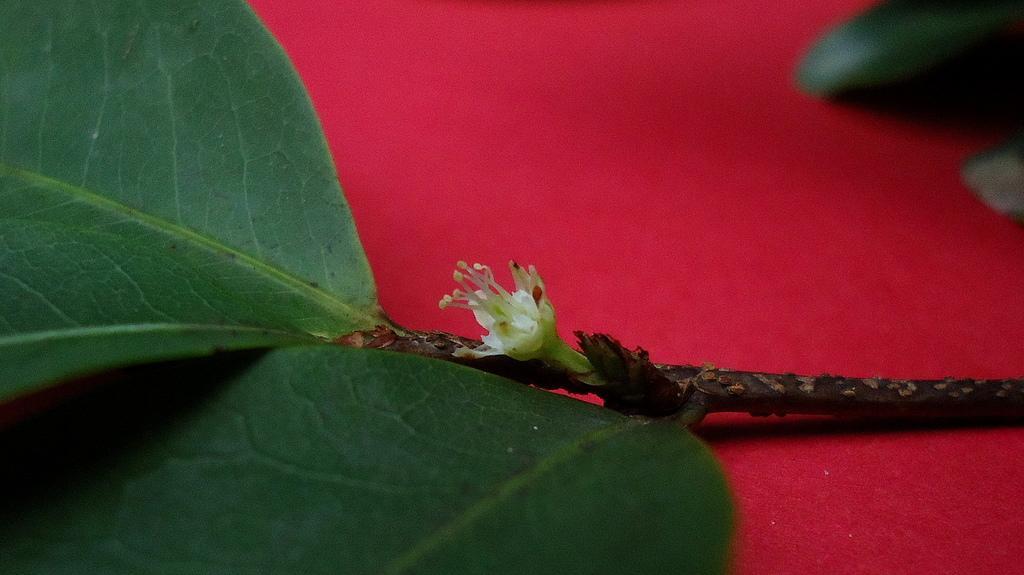Could you give a brief overview of what you see in this image? In this image there is a stem having a flower and leaves. The stem is kept on the surface which is in red color. Right top there is a leaf. 